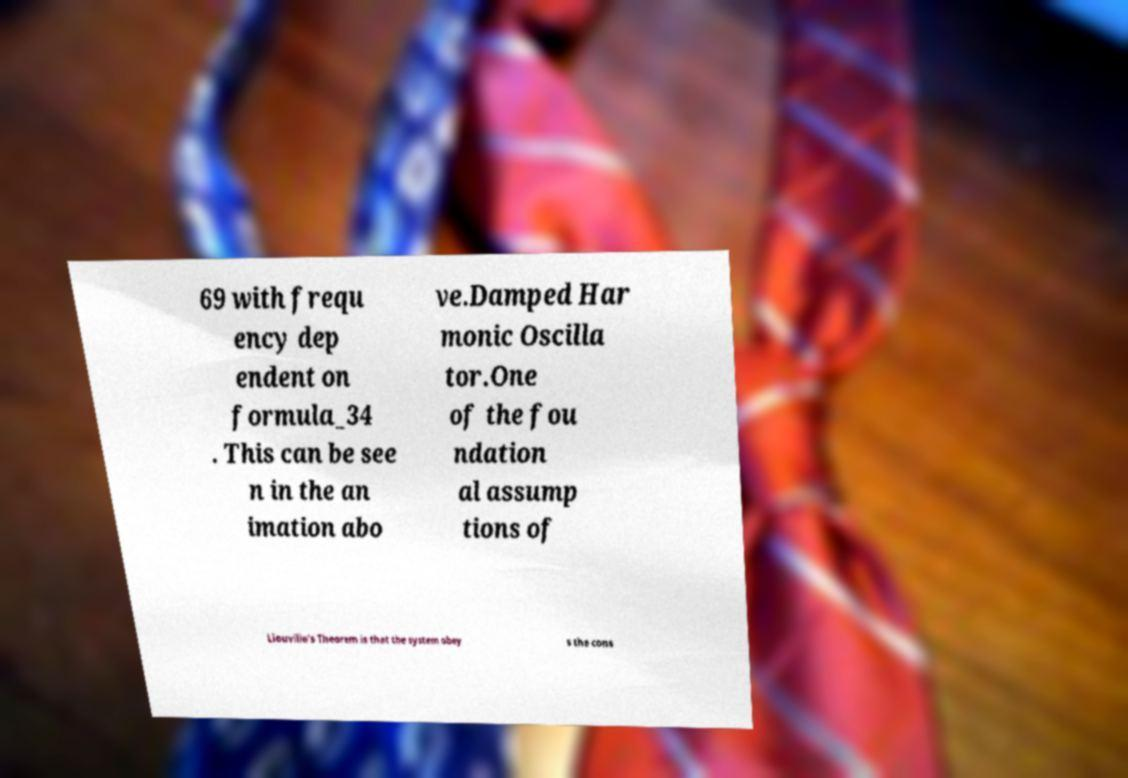For documentation purposes, I need the text within this image transcribed. Could you provide that? 69 with frequ ency dep endent on formula_34 . This can be see n in the an imation abo ve.Damped Har monic Oscilla tor.One of the fou ndation al assump tions of Liouville's Theorem is that the system obey s the cons 